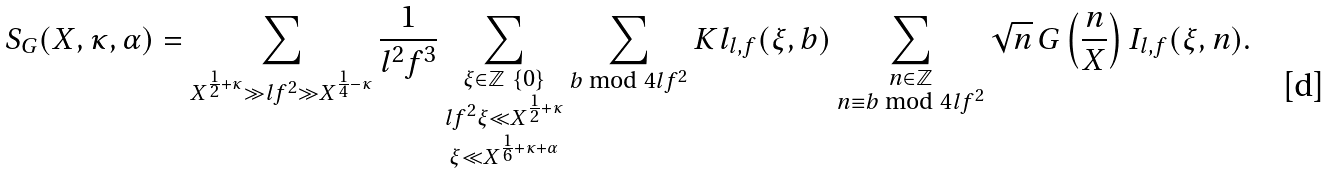<formula> <loc_0><loc_0><loc_500><loc_500>S _ { G } ( X , \kappa , \alpha ) = \sum _ { X ^ { \frac { 1 } { 2 } + \kappa } \gg l f ^ { 2 } \gg X ^ { \frac { 1 } { 4 } - \kappa } } \frac { 1 } { l ^ { 2 } f ^ { 3 } } \sum _ { \substack { \xi \in \mathbb { Z } \ \{ 0 \} \\ l f ^ { 2 } \xi \ll X ^ { \frac { 1 } { 2 } + \kappa } \\ \xi \ll X ^ { \frac { 1 } { 6 } + \kappa + \alpha } } } \sum _ { b \bmod 4 l f ^ { 2 } } K l _ { l , f } ( \xi , b ) \sum _ { \substack { n \in \mathbb { Z } \\ n \equiv b \bmod 4 l f ^ { 2 } } } \sqrt { n } \, G \left ( \frac { n } { X } \right ) I _ { l , f } ( \xi , n ) .</formula> 